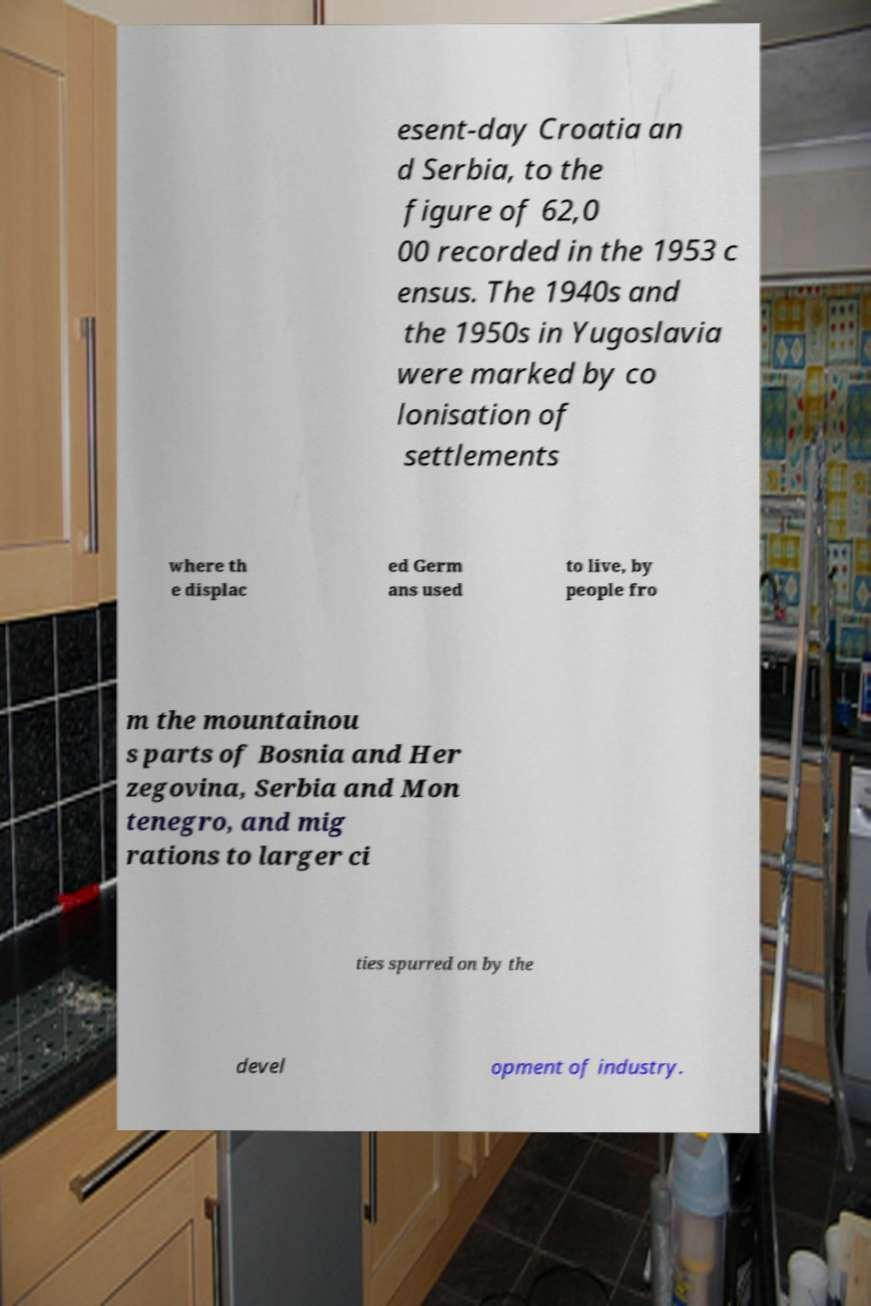Please identify and transcribe the text found in this image. esent-day Croatia an d Serbia, to the figure of 62,0 00 recorded in the 1953 c ensus. The 1940s and the 1950s in Yugoslavia were marked by co lonisation of settlements where th e displac ed Germ ans used to live, by people fro m the mountainou s parts of Bosnia and Her zegovina, Serbia and Mon tenegro, and mig rations to larger ci ties spurred on by the devel opment of industry. 